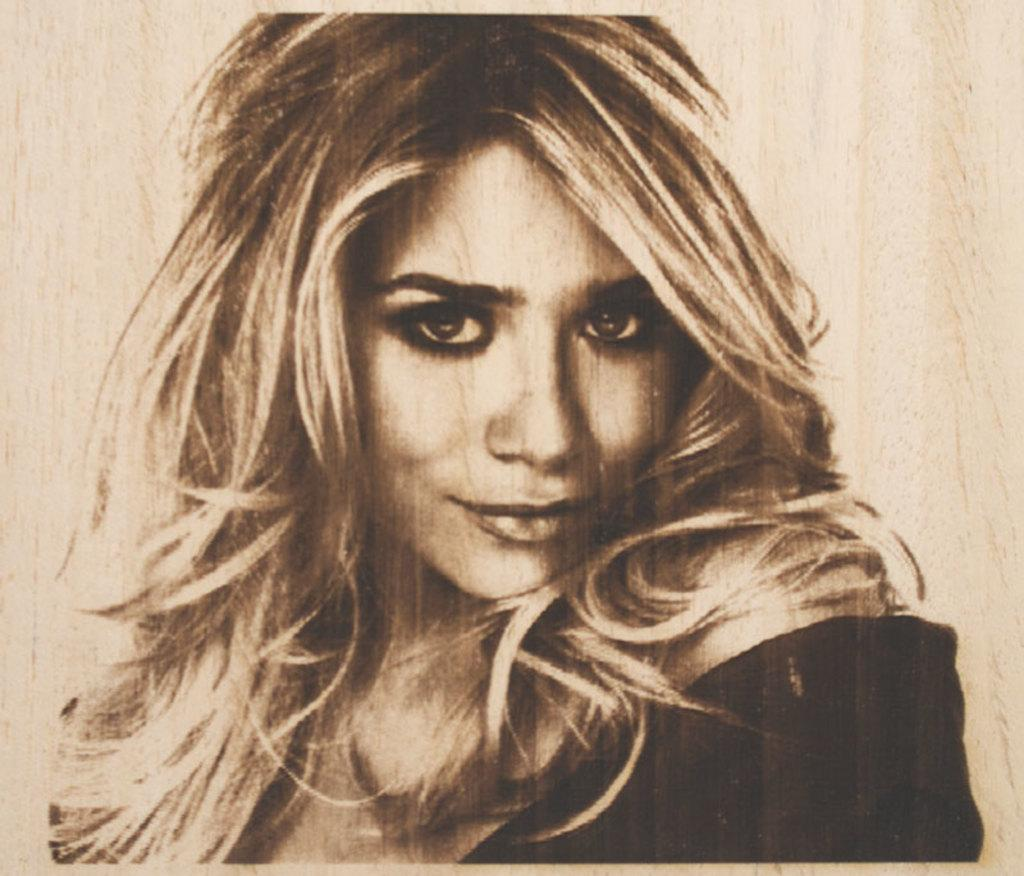What is the main subject of the image? The main subject of the image is a woman. How many cacti can be seen in the image? There are no cacti present in the image; it features a woman. What rule does the woman follow in the image? There is no rule mentioned or depicted in the image. 